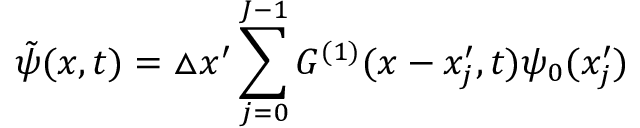<formula> <loc_0><loc_0><loc_500><loc_500>\tilde { \psi } ( x , t ) = \triangle x ^ { \prime } \sum _ { j = 0 } ^ { J - 1 } G ^ { ( 1 ) } ( x - x _ { j } ^ { \prime } , t ) \psi _ { 0 } ( x _ { j } ^ { \prime } )</formula> 